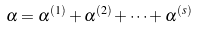Convert formula to latex. <formula><loc_0><loc_0><loc_500><loc_500>\alpha = \alpha ^ { ( 1 ) } + \alpha ^ { ( 2 ) } + \cdots + \alpha ^ { ( s ) }</formula> 